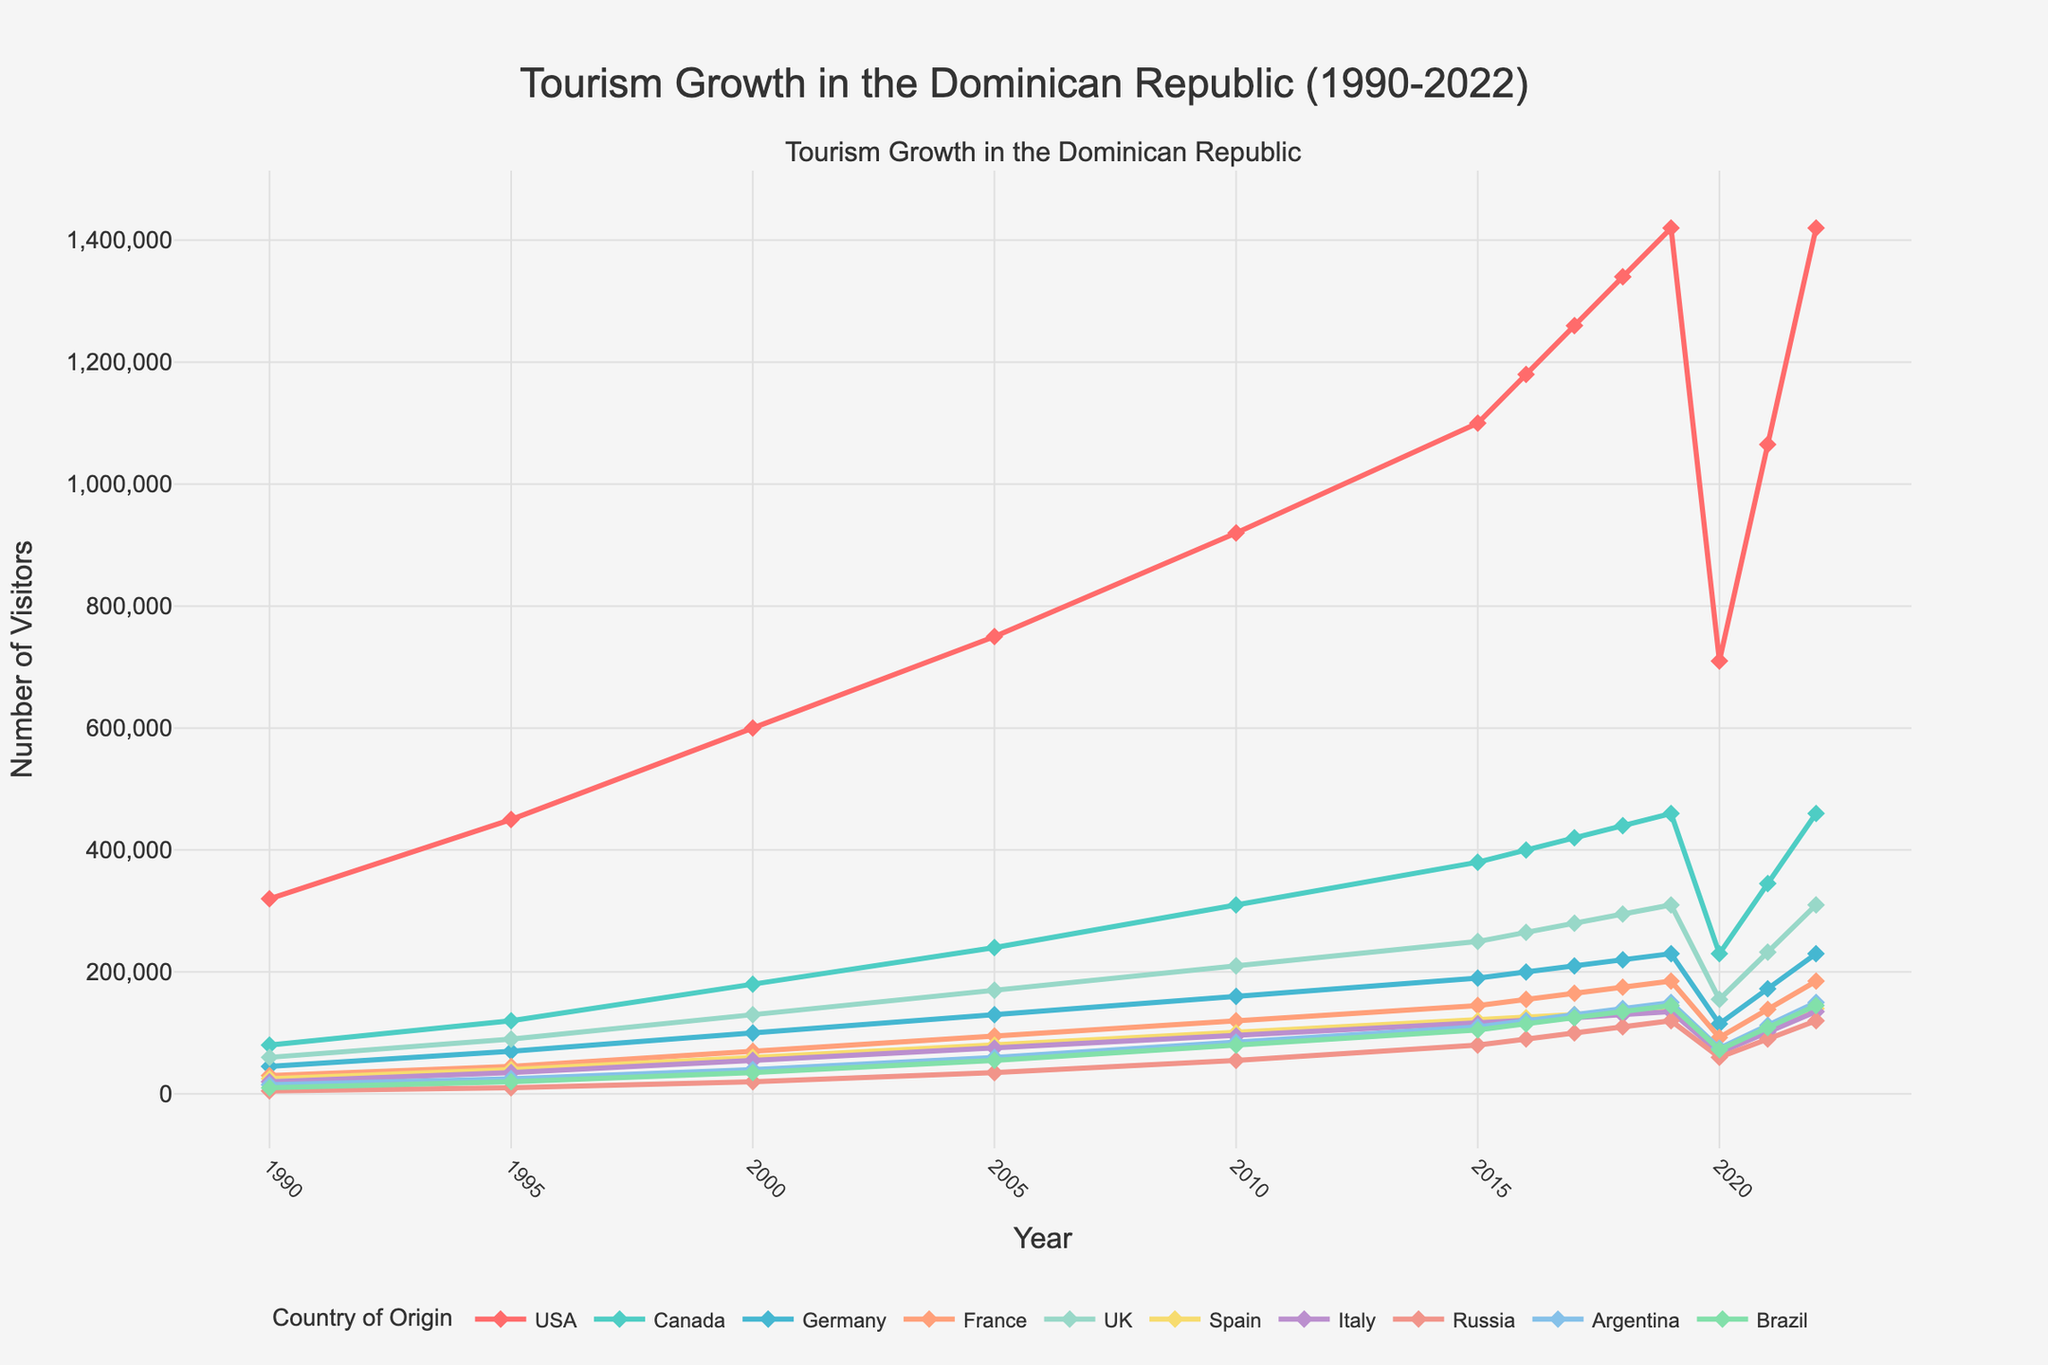Which country had the highest number of visitors to the Dominican Republic in 2018? By examining the plot, we see that the USA had the highest number of visitors in 2018.
Answer: USA Which two countries showed the closest number of visitors in 2022? By closely inspecting the lines and markers in the 2022 data, it appears that Argentina and Brazil had very similar visitor numbers.
Answer: Argentina and Brazil How did the number of visitors from the USA change from 1990 to 2022? The USA started with 320,000 visitors in 1990 and ended with 1,420,000 visitors in 2022. The increase can be calculated as 1,420,000 - 320,000 = 1,100,000.
Answer: Increased by 1,100,000 In which year did Canada have the largest increase in visitors compared to the previous year? Checking year over year, Canada had the largest increase from 1995 (120,000) to 2000 (180,000). The increase is 180,000 - 120,000 = 60,000.
Answer: 2000 Which country had the smallest number of visitors in 1995, and how many visitors were there? In 1995, Russia had the smallest number of visitors, indicated as 10,000 on the plot.
Answer: Russia with 10,000 visitors Compare the visitor growth of the UK and Germany from 2005 to 2010. Which country saw a higher increase? The UK increased from 170,000 to 210,000 (increase of 40,000) while Germany went from 130,000 to 160,000 (increase of 30,000). Therefore, the UK saw a higher increase.
Answer: UK What was the total number of visitors from Spain and Italy in the year 2000? Adding the numbers from the plot, Spain had 60,000 visitors and Italy had 55,000 visitors. The total is 60,000 + 55,000 = 115,000.
Answer: 115,000 Identify the year when visitors from Brazil reached their peak and state the number. From the visual plot, Brazil reached its peak in 2019 with 145,000 visitors.
Answer: 2019, 145,000 Visually, which country's visitor numbers displayed the most significant drop between 2019 and 2020? Examining the steepness of the drops, the USA experienced the most significant decline from 1,420,000 to 710,000, a drop of 710,000 visitors.
Answer: USA Which two countries had nearly parallel growth trajectories from 1990 to 2022? Observing the lines' growth paths, France and Germany had nearly parallel growth trajectories over the years.
Answer: France and Germany 